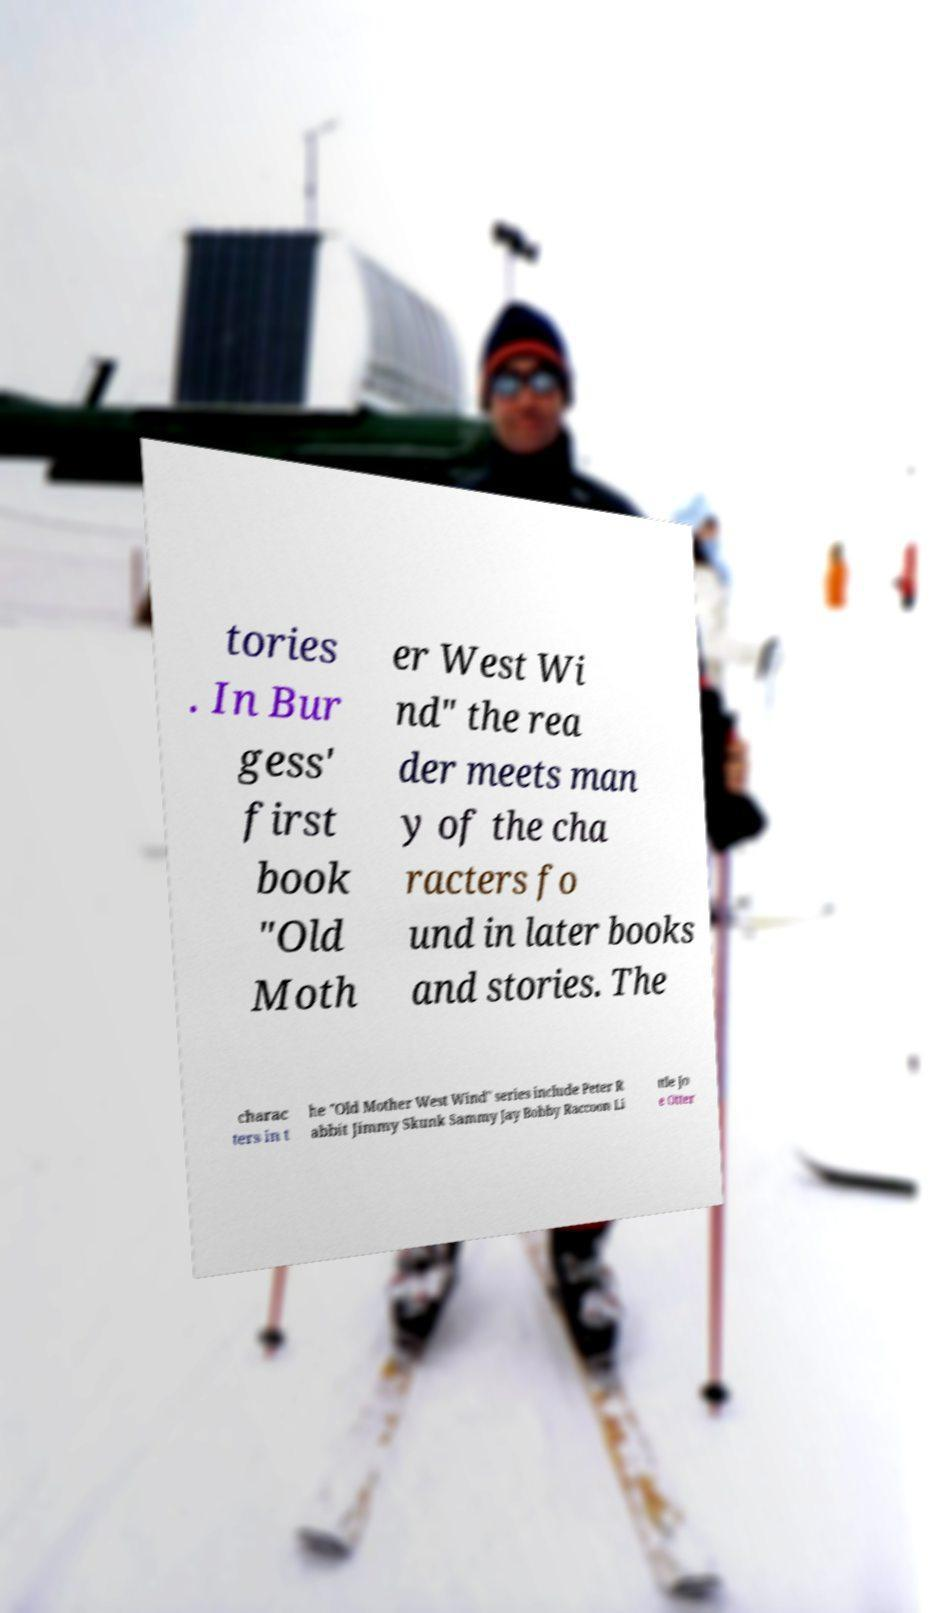Could you extract and type out the text from this image? tories . In Bur gess' first book "Old Moth er West Wi nd" the rea der meets man y of the cha racters fo und in later books and stories. The charac ters in t he "Old Mother West Wind" series include Peter R abbit Jimmy Skunk Sammy Jay Bobby Raccoon Li ttle Jo e Otter 